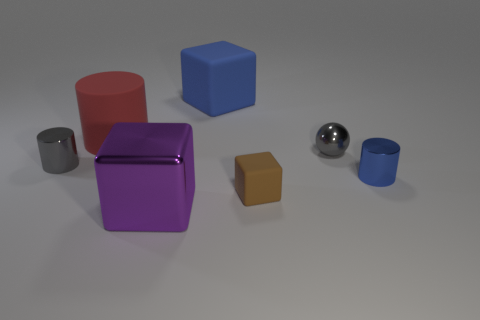The metal cylinder that is the same color as the small sphere is what size?
Make the answer very short. Small. How many things are tiny gray metallic cylinders or matte things to the right of the large metal cube?
Give a very brief answer. 3. Is the color of the sphere the same as the big metal object?
Provide a short and direct response. No. Is there a tiny sphere made of the same material as the tiny blue object?
Offer a terse response. Yes. There is another small matte thing that is the same shape as the purple thing; what color is it?
Offer a very short reply. Brown. Do the big purple object and the cylinder that is on the right side of the big cylinder have the same material?
Offer a terse response. Yes. What is the shape of the tiny gray metal object in front of the small gray thing on the right side of the big red cylinder?
Make the answer very short. Cylinder. There is a cube that is on the left side of the blue matte cube; does it have the same size as the brown matte cube?
Make the answer very short. No. What number of other things are there of the same shape as the red matte object?
Make the answer very short. 2. Do the tiny metallic cylinder to the left of the tiny blue cylinder and the small ball have the same color?
Your response must be concise. Yes. 